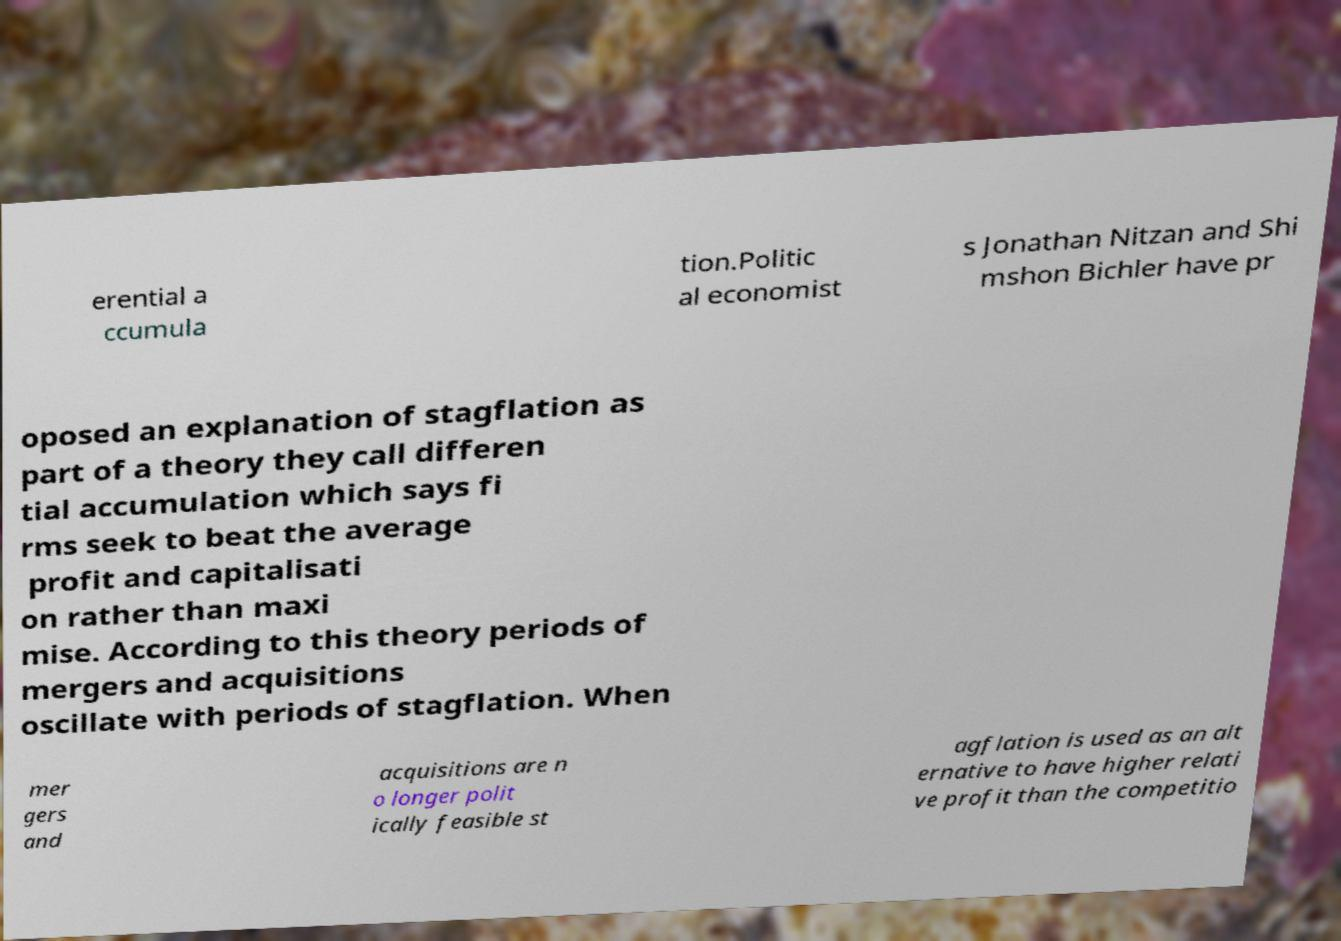Can you accurately transcribe the text from the provided image for me? erential a ccumula tion.Politic al economist s Jonathan Nitzan and Shi mshon Bichler have pr oposed an explanation of stagflation as part of a theory they call differen tial accumulation which says fi rms seek to beat the average profit and capitalisati on rather than maxi mise. According to this theory periods of mergers and acquisitions oscillate with periods of stagflation. When mer gers and acquisitions are n o longer polit ically feasible st agflation is used as an alt ernative to have higher relati ve profit than the competitio 